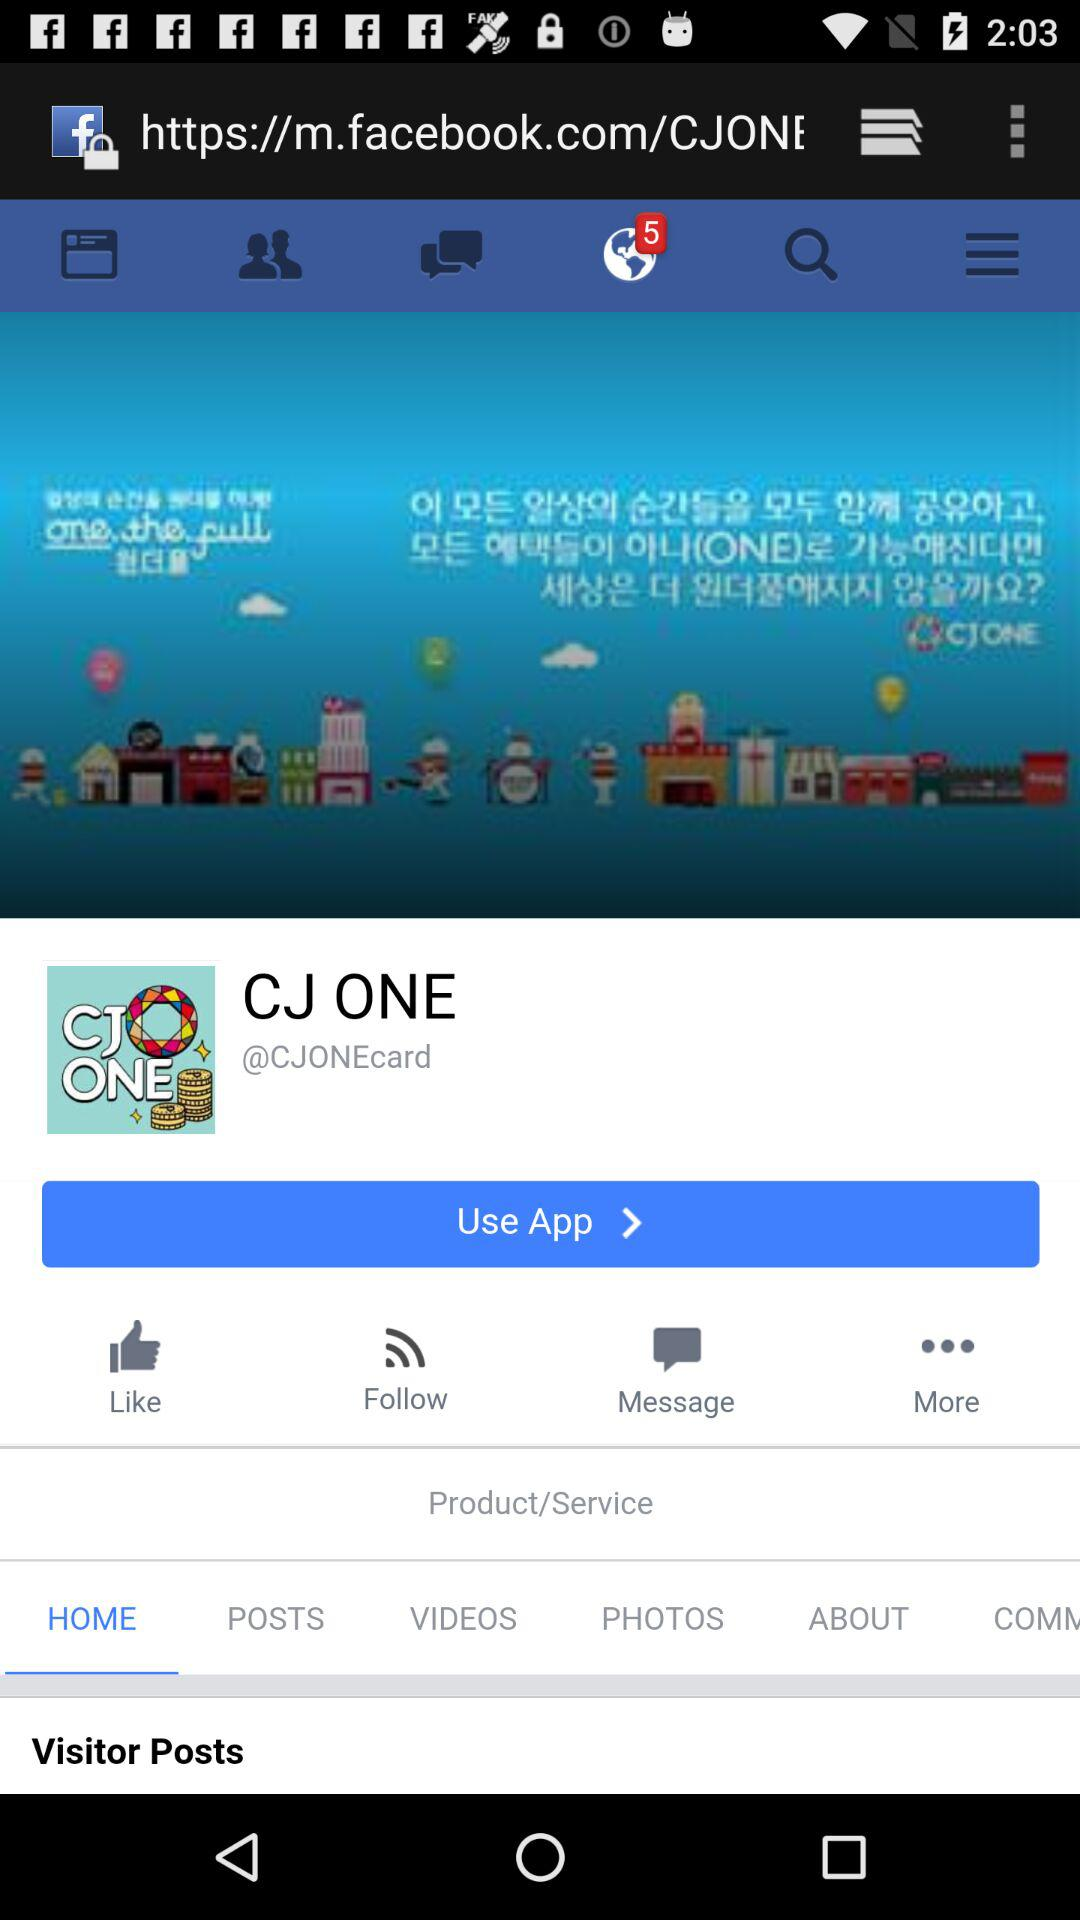What is the title of the page? The title is "CJ ONE". 